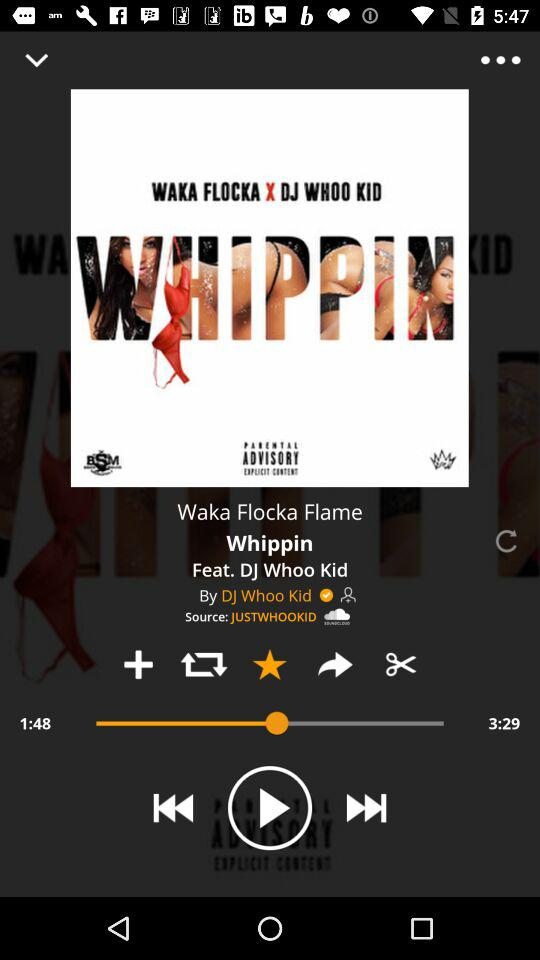Who is the singer? The singers are Waka Flocka Flame and DJ Whoo Kid. 